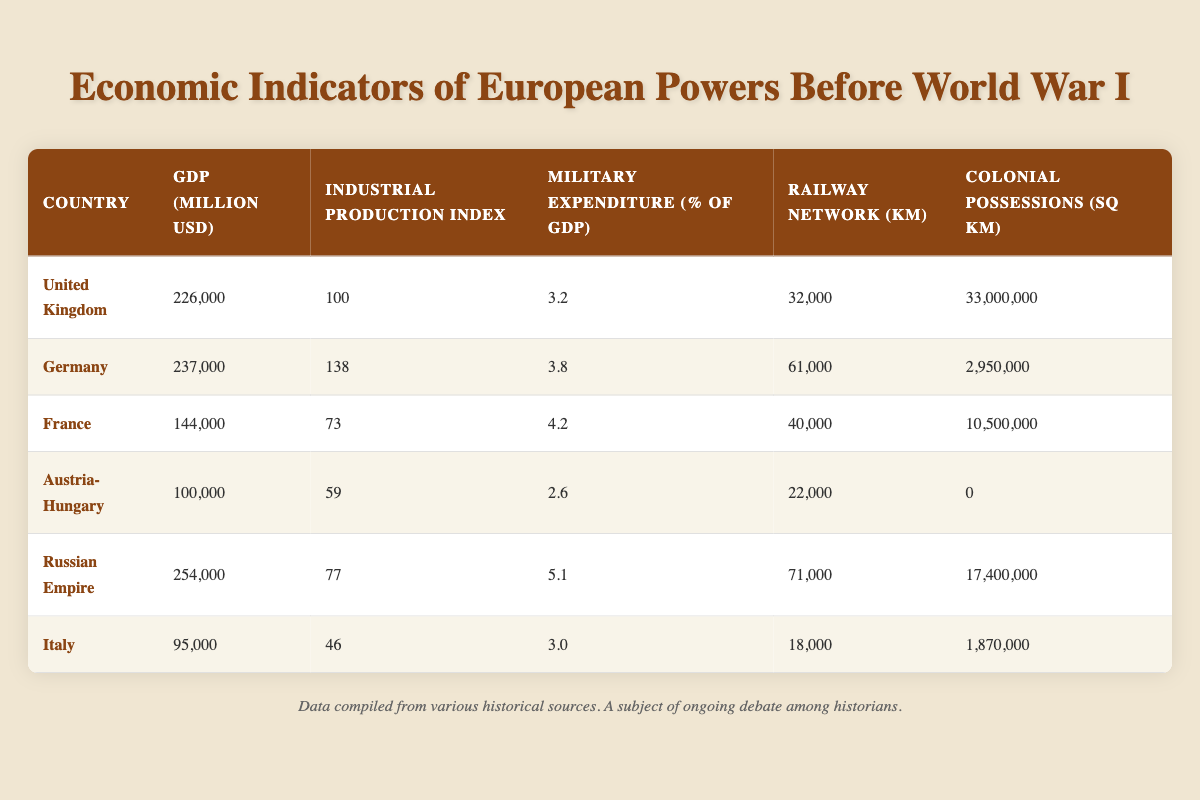What is the GDP of the German Empire? Referring to the table, the GDP value for Germany is located in the corresponding row under the GDP (million USD) column. It shows a value of 237,000 million USD.
Answer: 237,000 million USD Which country has the highest military expenditure as a percentage of GDP? By comparing the values in the Military Expenditure (% of GDP) column for all countries, the Russian Empire has the highest value of 5.1%.
Answer: Russian Empire What is the total number of railway kilometers for the United Kingdom and France combined? The railway kilometers for the United Kingdom is 32,000 km, while for France it is 40,000 km. Adding these two values gives 32,000 + 40,000 = 72,000 km.
Answer: 72,000 km Does Italy have any colonial possessions according to the data? Checking the Colonial Possessions (sq km) column for Italy shows a value of 1,870,000 sq km, which indicates that it does have colonial possessions.
Answer: Yes What is the average Industrial Production Index for the European powers listed? To find the average, we need to sum the values in the Industrial Production Index column: (100 + 138 + 73 + 59 + 77 + 46) = 493. There are 6 countries, so the average is 493 / 6 ≈ 82.17.
Answer: 82.17 